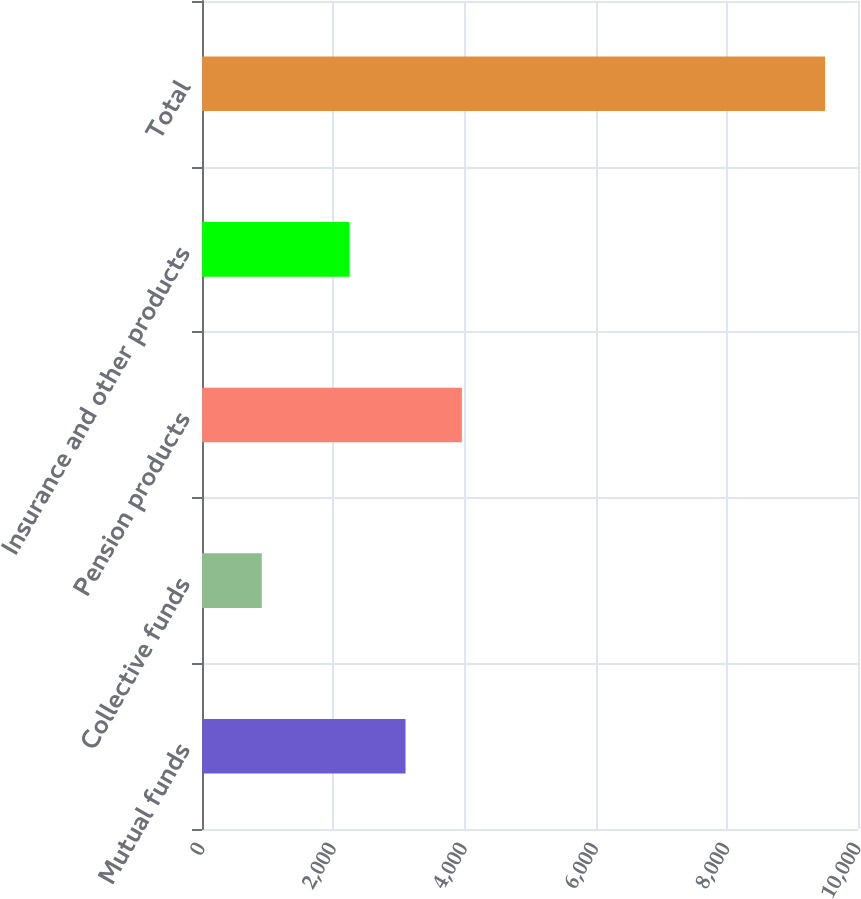<chart> <loc_0><loc_0><loc_500><loc_500><bar_chart><fcel>Mutual funds<fcel>Collective funds<fcel>Pension products<fcel>Insurance and other products<fcel>Total<nl><fcel>3102.6<fcel>911<fcel>3961.2<fcel>2244<fcel>9497<nl></chart> 